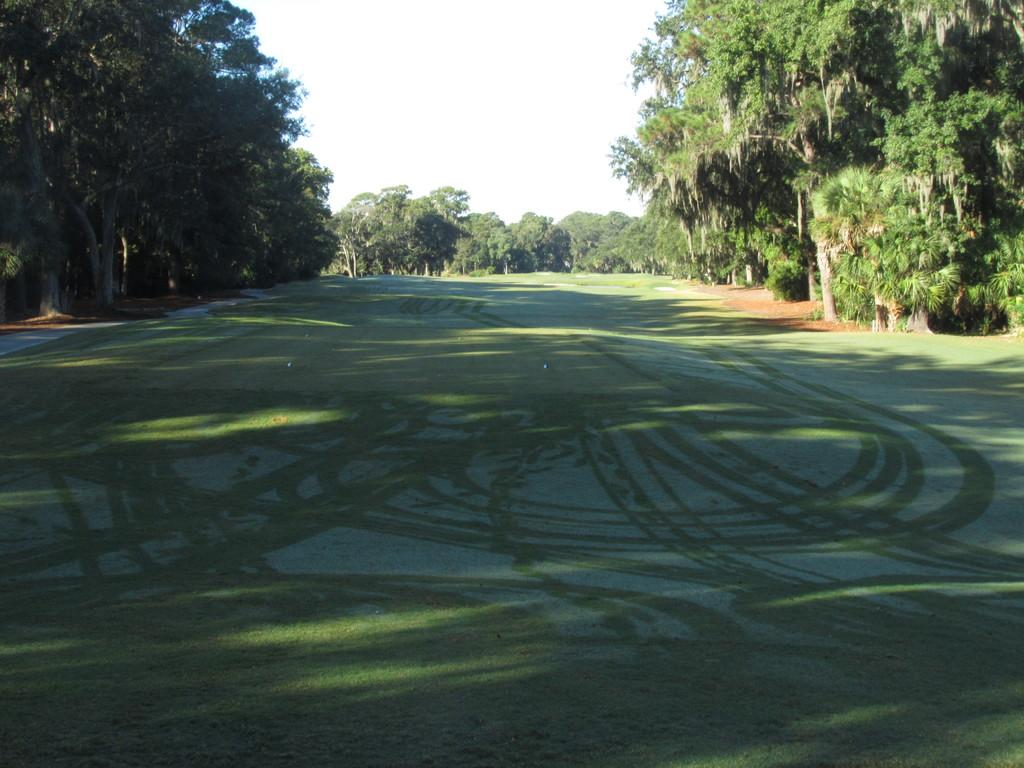What type of surface can be seen at the bottom of the image? The ground is visible in the image. What type of vegetation is present in the image? There is grass in the image. What can be seen in the distance in the image? There are many trees in the background of the image. What is visible at the top of the image? The sky is visible at the top of the image. What type of food is being prepared on the bike in the image? There is no bike or food present in the image. What kind of beast can be seen roaming in the grass in the image? There is no beast present in the image; it only features grass and trees. 